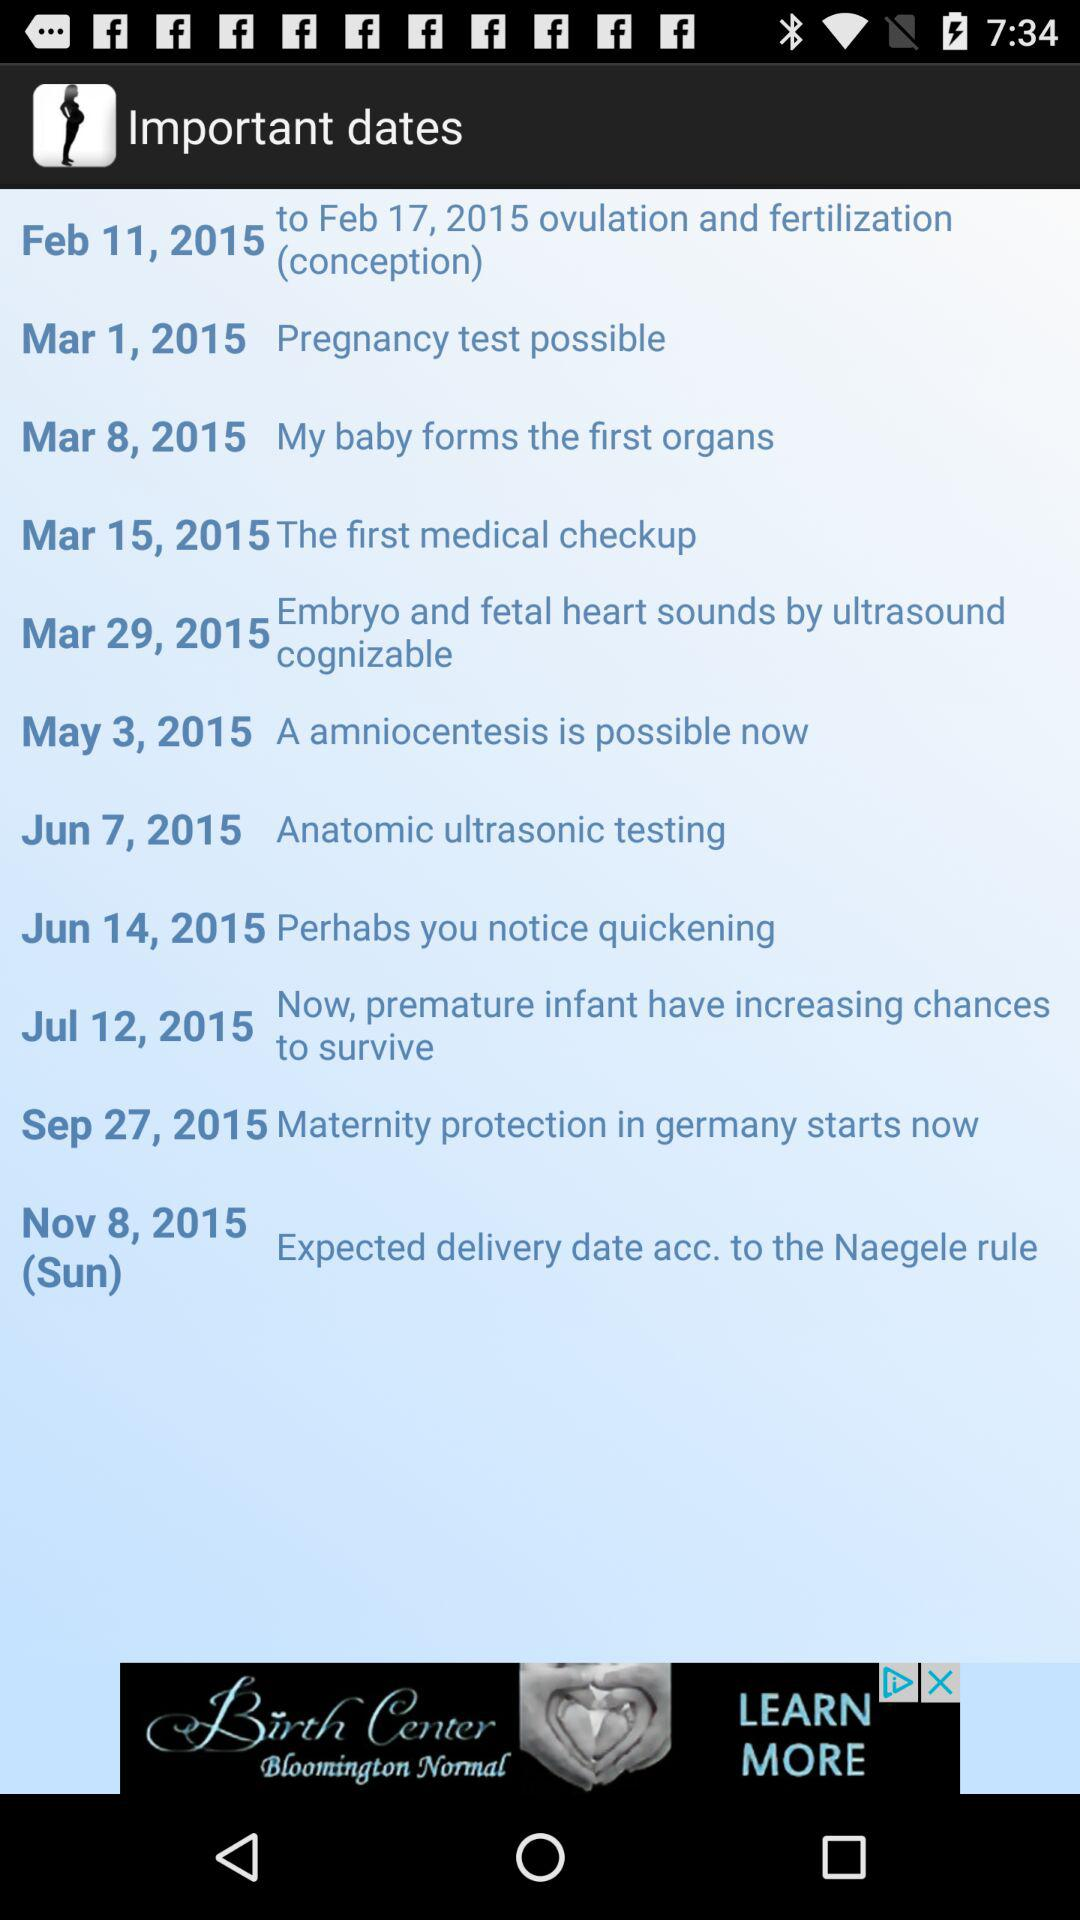What is the date for the anatomic ultrasonic testing? The date is June 7, 2015. 